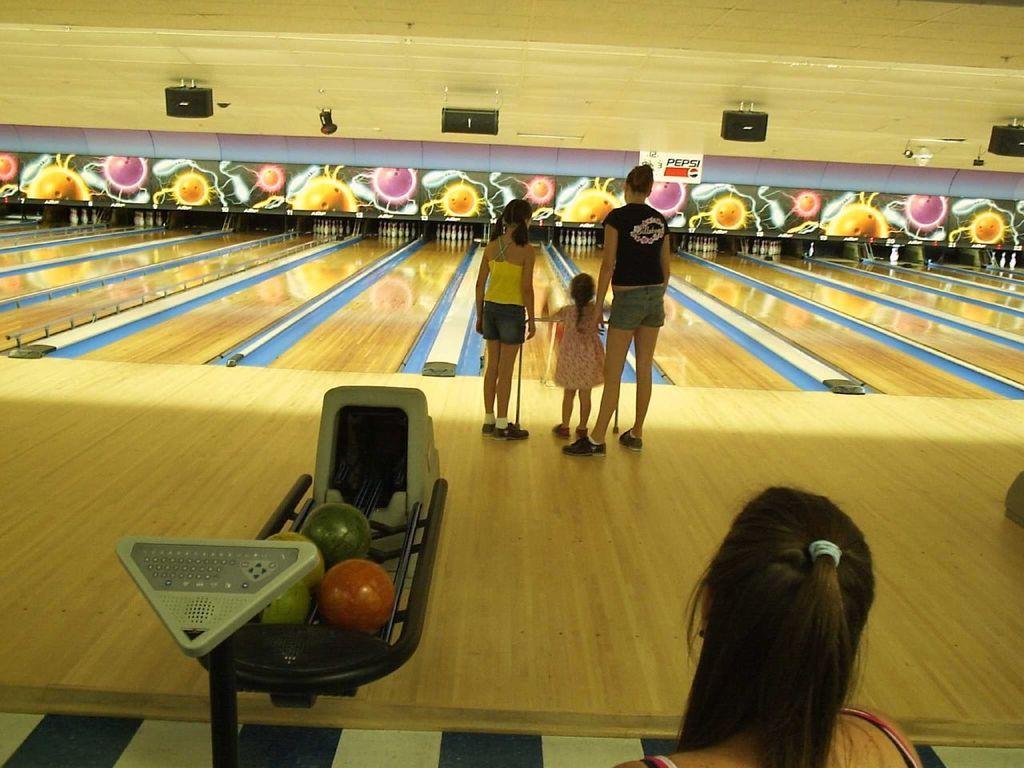How would you summarize this image in a sentence or two? Here is a woman and two girls standing. These are the bowling´s. This looks like a bowling area. I can see the bowling pins. These look like the wooden boards. Here is another woman. I can see the black color objects hanging to the roof. 